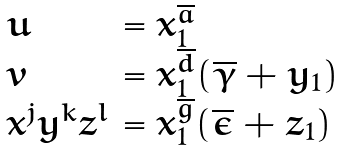Convert formula to latex. <formula><loc_0><loc_0><loc_500><loc_500>\begin{array} { l l } u & = x _ { 1 } ^ { \overline { a } } \\ v & = x _ { 1 } ^ { \overline { d } } ( \overline { \gamma } + y _ { 1 } ) \\ x ^ { j } y ^ { k } z ^ { l } & = x _ { 1 } ^ { \overline { g } } ( \overline { \epsilon } + z _ { 1 } ) \end{array}</formula> 